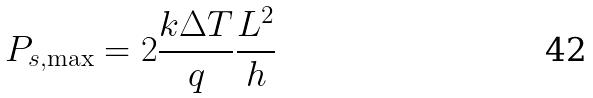Convert formula to latex. <formula><loc_0><loc_0><loc_500><loc_500>P _ { s , \max } = 2 \frac { k \Delta T } { q } \frac { L ^ { 2 } } { h }</formula> 